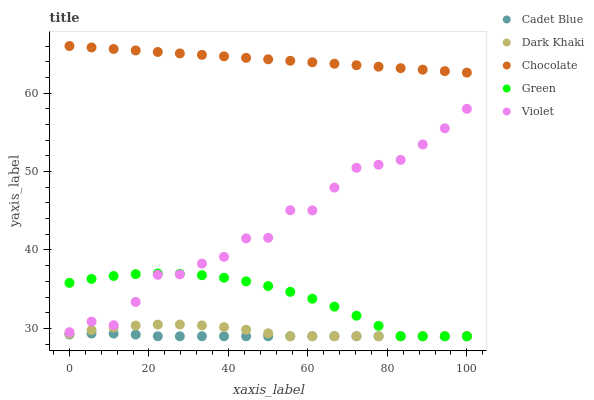Does Cadet Blue have the minimum area under the curve?
Answer yes or no. Yes. Does Chocolate have the maximum area under the curve?
Answer yes or no. Yes. Does Violet have the minimum area under the curve?
Answer yes or no. No. Does Violet have the maximum area under the curve?
Answer yes or no. No. Is Chocolate the smoothest?
Answer yes or no. Yes. Is Violet the roughest?
Answer yes or no. Yes. Is Cadet Blue the smoothest?
Answer yes or no. No. Is Cadet Blue the roughest?
Answer yes or no. No. Does Dark Khaki have the lowest value?
Answer yes or no. Yes. Does Violet have the lowest value?
Answer yes or no. No. Does Chocolate have the highest value?
Answer yes or no. Yes. Does Violet have the highest value?
Answer yes or no. No. Is Cadet Blue less than Chocolate?
Answer yes or no. Yes. Is Chocolate greater than Dark Khaki?
Answer yes or no. Yes. Does Dark Khaki intersect Cadet Blue?
Answer yes or no. Yes. Is Dark Khaki less than Cadet Blue?
Answer yes or no. No. Is Dark Khaki greater than Cadet Blue?
Answer yes or no. No. Does Cadet Blue intersect Chocolate?
Answer yes or no. No. 